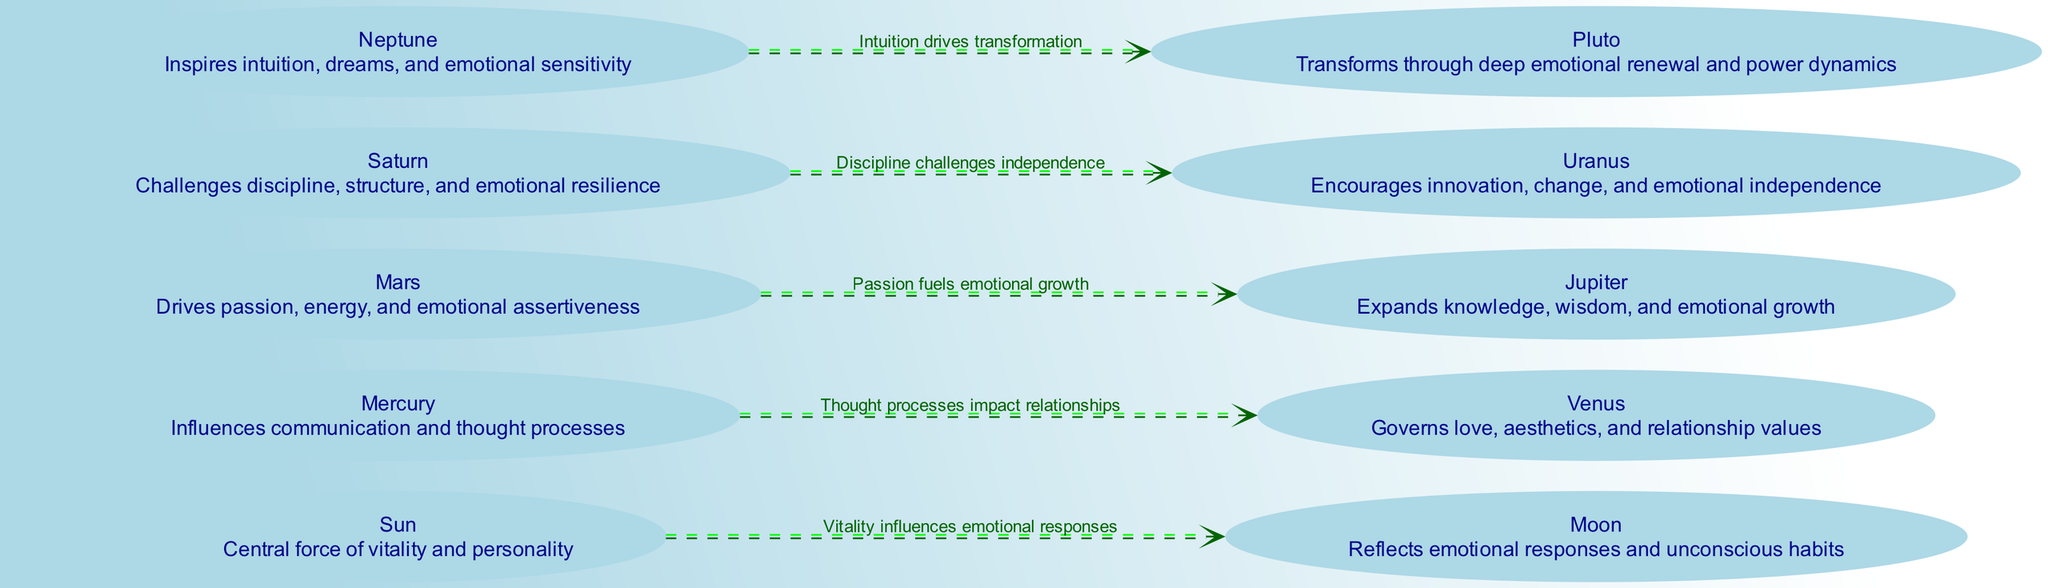What is the central node in the diagram? The central node is often referred to as the "Sun," which embodies the force of vitality and personality. This can be identified as it is the main node from which other nodes are influenced.
Answer: Sun How many nodes are in the diagram? By counting all the celestial bodies represented in the nodes section, we find that there are ten nodes, each representing an influence on emotional intelligence.
Answer: 10 What does the Moon govern? The Moon governs emotional responses and unconscious habits, as described in the node information provided in the diagram.
Answer: Emotional responses and unconscious habits Which celestial body is associated with communication? That would be Mercury, which influences communication and thought processes, making it crucial for emotional expression.
Answer: Mercury What relationship does Mars have with Jupiter? Mars drives passion and energy, which fuels emotional growth associated with Jupiter, indicating a direct influential relationship between these two nodes.
Answer: Passion fuels emotional growth What challenges does Saturn present? Saturn challenges discipline and structure, which inherently tests emotional resilience in the framework of influencing emotional intelligence.
Answer: Discipline and emotional resilience Which node reflects intuition? The node that reflects intuition is Neptune, as it inspires intuition, dreams, and emotional sensitivity, making it significant in the context of emotional awareness.
Answer: Neptune How many edges are there in the diagram? Counting the edges that connect the nodes, there are five edges that represent the relationships and influences among celestial bodies depicted in this diagram.
Answer: 5 What does Neptune influence? Neptune influences intuition, dreams, and emotional sensitivity, establishing a vital link in the emotional intelligence framework illustrated in the diagram.
Answer: Intuition, dreams, and emotional sensitivity What role does Uranus play in the diagram? Uranus encourages innovation and emotional independence, which highlights its unique role in promoting self-awareness and emotional intelligence.
Answer: Innovation and emotional independence 